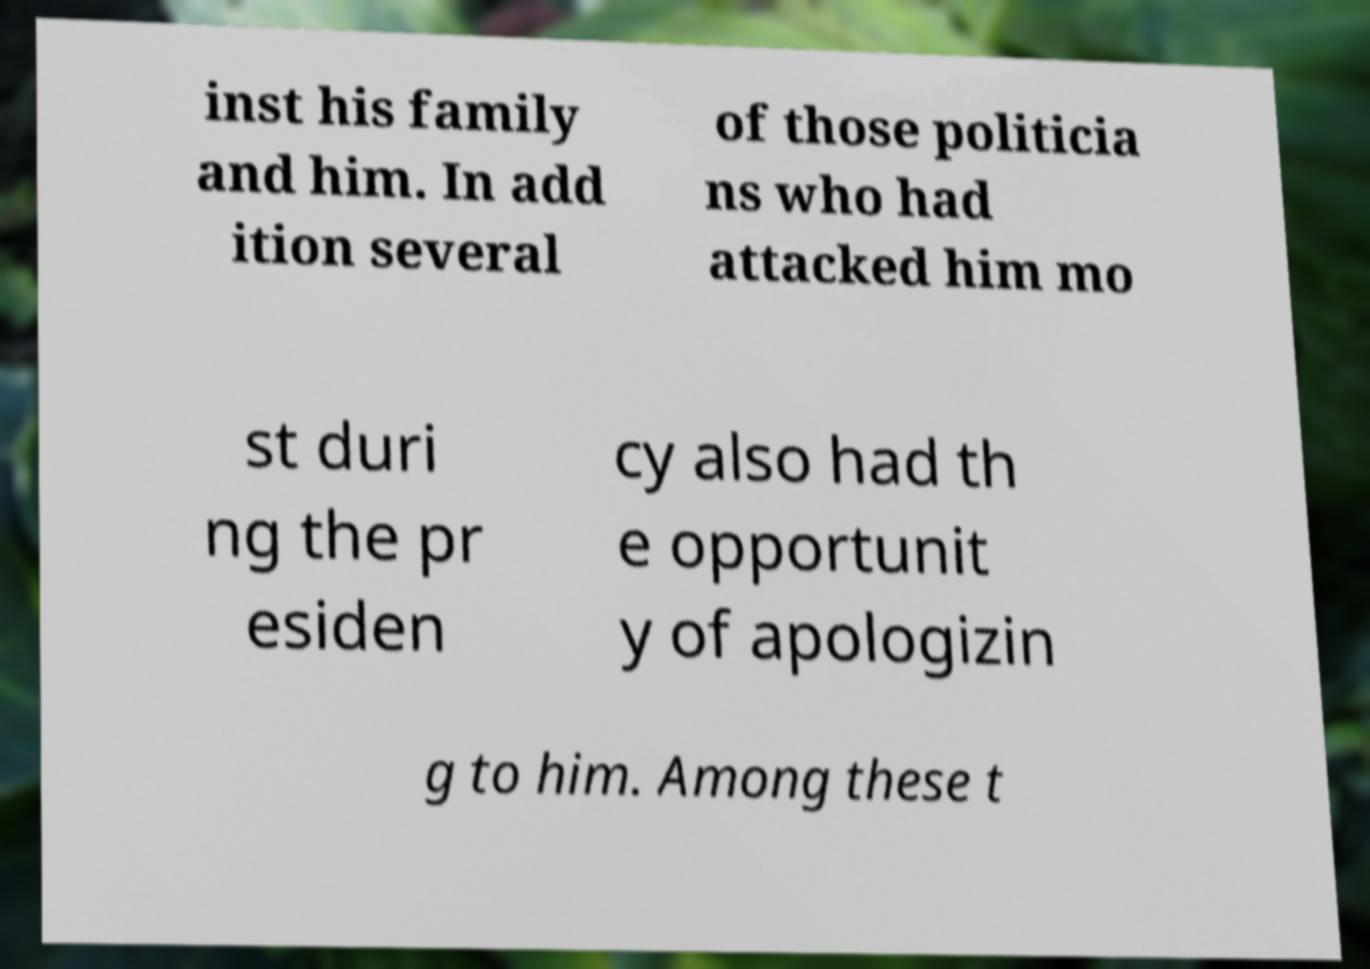Please identify and transcribe the text found in this image. inst his family and him. In add ition several of those politicia ns who had attacked him mo st duri ng the pr esiden cy also had th e opportunit y of apologizin g to him. Among these t 